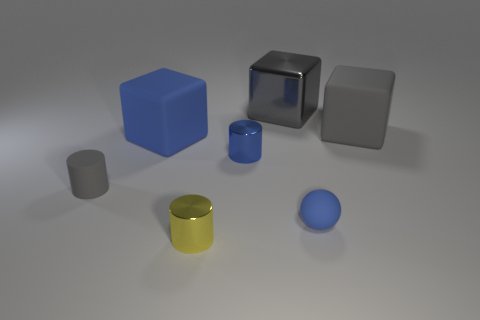The thing that is in front of the tiny gray rubber object and to the left of the large metal cube is made of what material?
Ensure brevity in your answer.  Metal. Is the number of cylinders that are left of the small yellow shiny cylinder less than the number of tiny cylinders in front of the big metallic cube?
Give a very brief answer. Yes. How many other things are there of the same size as the blue matte cube?
Provide a succinct answer. 2. What shape is the tiny thing that is in front of the blue ball on the right side of the blue cylinder that is on the right side of the big blue object?
Your answer should be very brief. Cylinder. How many red things are either metallic blocks or spheres?
Your answer should be compact. 0. How many blue things are on the right side of the tiny metallic thing behind the rubber cylinder?
Give a very brief answer. 1. Are there any other things that are the same color as the matte cylinder?
Your answer should be very brief. Yes. There is a blue object that is made of the same material as the blue ball; what shape is it?
Your answer should be compact. Cube. Do the matte cylinder and the shiny cube have the same color?
Your answer should be compact. Yes. Are the yellow object that is left of the gray matte cube and the gray thing in front of the large blue object made of the same material?
Give a very brief answer. No. 